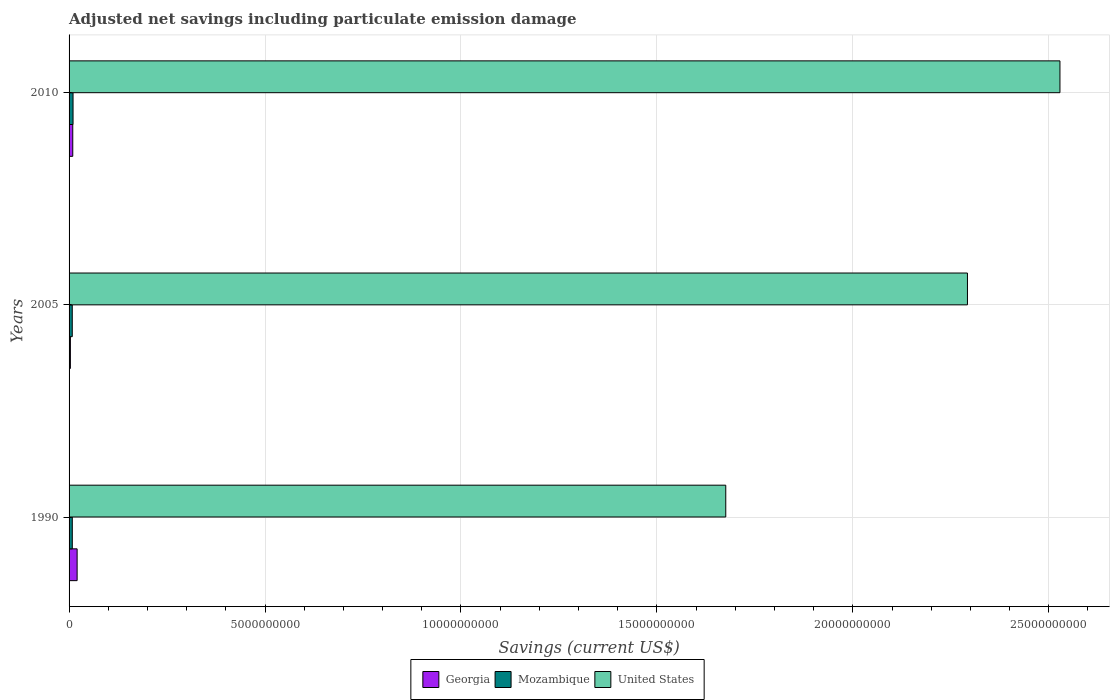How many different coloured bars are there?
Provide a succinct answer. 3. Are the number of bars per tick equal to the number of legend labels?
Offer a very short reply. Yes. Are the number of bars on each tick of the Y-axis equal?
Your answer should be compact. Yes. How many bars are there on the 1st tick from the bottom?
Offer a very short reply. 3. In how many cases, is the number of bars for a given year not equal to the number of legend labels?
Offer a terse response. 0. What is the net savings in United States in 2005?
Offer a terse response. 2.29e+1. Across all years, what is the maximum net savings in Georgia?
Your answer should be compact. 2.06e+08. Across all years, what is the minimum net savings in United States?
Make the answer very short. 1.68e+1. In which year was the net savings in Georgia minimum?
Keep it short and to the point. 2005. What is the total net savings in Georgia in the graph?
Ensure brevity in your answer.  3.34e+08. What is the difference between the net savings in Mozambique in 1990 and that in 2010?
Make the answer very short. -1.90e+07. What is the difference between the net savings in Mozambique in 1990 and the net savings in United States in 2005?
Your answer should be compact. -2.28e+1. What is the average net savings in United States per year?
Keep it short and to the point. 2.17e+1. In the year 2010, what is the difference between the net savings in Mozambique and net savings in Georgia?
Make the answer very short. 7.03e+06. What is the ratio of the net savings in Georgia in 1990 to that in 2005?
Offer a terse response. 6.1. Is the difference between the net savings in Mozambique in 1990 and 2010 greater than the difference between the net savings in Georgia in 1990 and 2010?
Keep it short and to the point. No. What is the difference between the highest and the second highest net savings in Georgia?
Keep it short and to the point. 1.11e+08. What is the difference between the highest and the lowest net savings in Mozambique?
Offer a terse response. 1.96e+07. Is the sum of the net savings in Georgia in 2005 and 2010 greater than the maximum net savings in Mozambique across all years?
Your response must be concise. Yes. What does the 3rd bar from the top in 2010 represents?
Offer a terse response. Georgia. What does the 2nd bar from the bottom in 2010 represents?
Offer a very short reply. Mozambique. Are the values on the major ticks of X-axis written in scientific E-notation?
Ensure brevity in your answer.  No. Does the graph contain any zero values?
Your answer should be very brief. No. What is the title of the graph?
Keep it short and to the point. Adjusted net savings including particulate emission damage. What is the label or title of the X-axis?
Give a very brief answer. Savings (current US$). What is the Savings (current US$) in Georgia in 1990?
Your answer should be compact. 2.06e+08. What is the Savings (current US$) of Mozambique in 1990?
Offer a very short reply. 8.24e+07. What is the Savings (current US$) in United States in 1990?
Your answer should be very brief. 1.68e+1. What is the Savings (current US$) of Georgia in 2005?
Provide a succinct answer. 3.37e+07. What is the Savings (current US$) of Mozambique in 2005?
Your answer should be compact. 8.17e+07. What is the Savings (current US$) of United States in 2005?
Your answer should be very brief. 2.29e+1. What is the Savings (current US$) of Georgia in 2010?
Offer a terse response. 9.43e+07. What is the Savings (current US$) of Mozambique in 2010?
Make the answer very short. 1.01e+08. What is the Savings (current US$) of United States in 2010?
Keep it short and to the point. 2.53e+1. Across all years, what is the maximum Savings (current US$) in Georgia?
Your answer should be very brief. 2.06e+08. Across all years, what is the maximum Savings (current US$) of Mozambique?
Ensure brevity in your answer.  1.01e+08. Across all years, what is the maximum Savings (current US$) of United States?
Provide a short and direct response. 2.53e+1. Across all years, what is the minimum Savings (current US$) of Georgia?
Your answer should be compact. 3.37e+07. Across all years, what is the minimum Savings (current US$) of Mozambique?
Keep it short and to the point. 8.17e+07. Across all years, what is the minimum Savings (current US$) in United States?
Provide a succinct answer. 1.68e+1. What is the total Savings (current US$) of Georgia in the graph?
Offer a terse response. 3.34e+08. What is the total Savings (current US$) in Mozambique in the graph?
Your answer should be very brief. 2.65e+08. What is the total Savings (current US$) in United States in the graph?
Provide a succinct answer. 6.50e+1. What is the difference between the Savings (current US$) in Georgia in 1990 and that in 2005?
Offer a terse response. 1.72e+08. What is the difference between the Savings (current US$) in Mozambique in 1990 and that in 2005?
Give a very brief answer. 6.39e+05. What is the difference between the Savings (current US$) in United States in 1990 and that in 2005?
Ensure brevity in your answer.  -6.17e+09. What is the difference between the Savings (current US$) in Georgia in 1990 and that in 2010?
Give a very brief answer. 1.11e+08. What is the difference between the Savings (current US$) in Mozambique in 1990 and that in 2010?
Your answer should be very brief. -1.90e+07. What is the difference between the Savings (current US$) of United States in 1990 and that in 2010?
Offer a very short reply. -8.53e+09. What is the difference between the Savings (current US$) of Georgia in 2005 and that in 2010?
Your answer should be compact. -6.06e+07. What is the difference between the Savings (current US$) of Mozambique in 2005 and that in 2010?
Keep it short and to the point. -1.96e+07. What is the difference between the Savings (current US$) of United States in 2005 and that in 2010?
Make the answer very short. -2.36e+09. What is the difference between the Savings (current US$) in Georgia in 1990 and the Savings (current US$) in Mozambique in 2005?
Give a very brief answer. 1.24e+08. What is the difference between the Savings (current US$) of Georgia in 1990 and the Savings (current US$) of United States in 2005?
Ensure brevity in your answer.  -2.27e+1. What is the difference between the Savings (current US$) in Mozambique in 1990 and the Savings (current US$) in United States in 2005?
Give a very brief answer. -2.28e+1. What is the difference between the Savings (current US$) in Georgia in 1990 and the Savings (current US$) in Mozambique in 2010?
Keep it short and to the point. 1.04e+08. What is the difference between the Savings (current US$) in Georgia in 1990 and the Savings (current US$) in United States in 2010?
Your response must be concise. -2.51e+1. What is the difference between the Savings (current US$) of Mozambique in 1990 and the Savings (current US$) of United States in 2010?
Keep it short and to the point. -2.52e+1. What is the difference between the Savings (current US$) of Georgia in 2005 and the Savings (current US$) of Mozambique in 2010?
Provide a succinct answer. -6.76e+07. What is the difference between the Savings (current US$) of Georgia in 2005 and the Savings (current US$) of United States in 2010?
Offer a terse response. -2.53e+1. What is the difference between the Savings (current US$) of Mozambique in 2005 and the Savings (current US$) of United States in 2010?
Make the answer very short. -2.52e+1. What is the average Savings (current US$) in Georgia per year?
Your answer should be compact. 1.11e+08. What is the average Savings (current US$) in Mozambique per year?
Ensure brevity in your answer.  8.85e+07. What is the average Savings (current US$) of United States per year?
Keep it short and to the point. 2.17e+1. In the year 1990, what is the difference between the Savings (current US$) in Georgia and Savings (current US$) in Mozambique?
Ensure brevity in your answer.  1.23e+08. In the year 1990, what is the difference between the Savings (current US$) in Georgia and Savings (current US$) in United States?
Provide a succinct answer. -1.66e+1. In the year 1990, what is the difference between the Savings (current US$) in Mozambique and Savings (current US$) in United States?
Give a very brief answer. -1.67e+1. In the year 2005, what is the difference between the Savings (current US$) of Georgia and Savings (current US$) of Mozambique?
Your response must be concise. -4.80e+07. In the year 2005, what is the difference between the Savings (current US$) in Georgia and Savings (current US$) in United States?
Ensure brevity in your answer.  -2.29e+1. In the year 2005, what is the difference between the Savings (current US$) of Mozambique and Savings (current US$) of United States?
Offer a terse response. -2.28e+1. In the year 2010, what is the difference between the Savings (current US$) in Georgia and Savings (current US$) in Mozambique?
Provide a short and direct response. -7.03e+06. In the year 2010, what is the difference between the Savings (current US$) in Georgia and Savings (current US$) in United States?
Ensure brevity in your answer.  -2.52e+1. In the year 2010, what is the difference between the Savings (current US$) in Mozambique and Savings (current US$) in United States?
Offer a terse response. -2.52e+1. What is the ratio of the Savings (current US$) in Georgia in 1990 to that in 2005?
Ensure brevity in your answer.  6.1. What is the ratio of the Savings (current US$) in Mozambique in 1990 to that in 2005?
Give a very brief answer. 1.01. What is the ratio of the Savings (current US$) of United States in 1990 to that in 2005?
Your answer should be very brief. 0.73. What is the ratio of the Savings (current US$) in Georgia in 1990 to that in 2010?
Your answer should be very brief. 2.18. What is the ratio of the Savings (current US$) of Mozambique in 1990 to that in 2010?
Provide a short and direct response. 0.81. What is the ratio of the Savings (current US$) in United States in 1990 to that in 2010?
Offer a very short reply. 0.66. What is the ratio of the Savings (current US$) in Georgia in 2005 to that in 2010?
Ensure brevity in your answer.  0.36. What is the ratio of the Savings (current US$) of Mozambique in 2005 to that in 2010?
Keep it short and to the point. 0.81. What is the ratio of the Savings (current US$) of United States in 2005 to that in 2010?
Your answer should be compact. 0.91. What is the difference between the highest and the second highest Savings (current US$) of Georgia?
Your answer should be compact. 1.11e+08. What is the difference between the highest and the second highest Savings (current US$) in Mozambique?
Keep it short and to the point. 1.90e+07. What is the difference between the highest and the second highest Savings (current US$) of United States?
Your response must be concise. 2.36e+09. What is the difference between the highest and the lowest Savings (current US$) in Georgia?
Keep it short and to the point. 1.72e+08. What is the difference between the highest and the lowest Savings (current US$) of Mozambique?
Offer a terse response. 1.96e+07. What is the difference between the highest and the lowest Savings (current US$) in United States?
Give a very brief answer. 8.53e+09. 